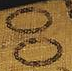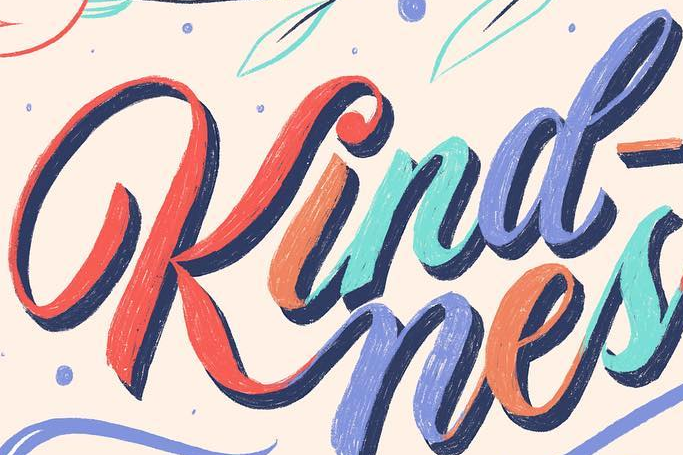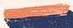What words are shown in these images in order, separated by a semicolon? OO; Kind; - 